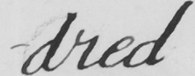Transcribe the text shown in this historical manuscript line. -dred 